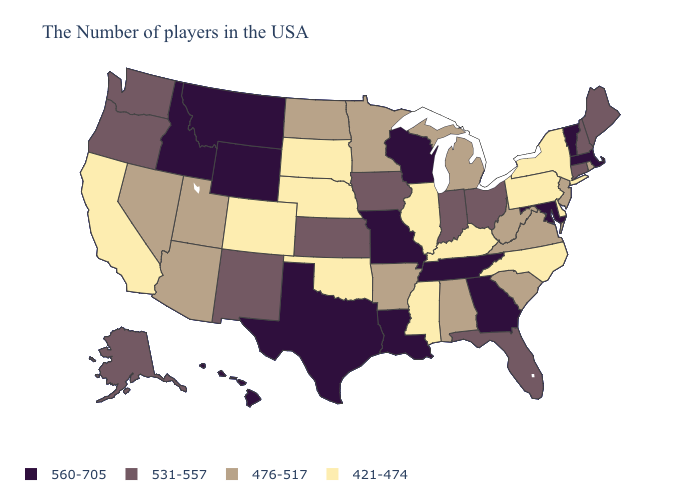Name the states that have a value in the range 476-517?
Write a very short answer. Rhode Island, New Jersey, Virginia, South Carolina, West Virginia, Michigan, Alabama, Arkansas, Minnesota, North Dakota, Utah, Arizona, Nevada. Which states have the lowest value in the Northeast?
Write a very short answer. New York, Pennsylvania. Does Delaware have the same value as Maine?
Write a very short answer. No. Name the states that have a value in the range 560-705?
Write a very short answer. Massachusetts, Vermont, Maryland, Georgia, Tennessee, Wisconsin, Louisiana, Missouri, Texas, Wyoming, Montana, Idaho, Hawaii. Name the states that have a value in the range 476-517?
Be succinct. Rhode Island, New Jersey, Virginia, South Carolina, West Virginia, Michigan, Alabama, Arkansas, Minnesota, North Dakota, Utah, Arizona, Nevada. What is the lowest value in the South?
Keep it brief. 421-474. Among the states that border Mississippi , does Arkansas have the highest value?
Keep it brief. No. Name the states that have a value in the range 560-705?
Be succinct. Massachusetts, Vermont, Maryland, Georgia, Tennessee, Wisconsin, Louisiana, Missouri, Texas, Wyoming, Montana, Idaho, Hawaii. Among the states that border Nebraska , which have the lowest value?
Short answer required. South Dakota, Colorado. How many symbols are there in the legend?
Short answer required. 4. Name the states that have a value in the range 421-474?
Concise answer only. New York, Delaware, Pennsylvania, North Carolina, Kentucky, Illinois, Mississippi, Nebraska, Oklahoma, South Dakota, Colorado, California. What is the lowest value in the USA?
Give a very brief answer. 421-474. Which states have the lowest value in the USA?
Give a very brief answer. New York, Delaware, Pennsylvania, North Carolina, Kentucky, Illinois, Mississippi, Nebraska, Oklahoma, South Dakota, Colorado, California. Which states have the lowest value in the USA?
Short answer required. New York, Delaware, Pennsylvania, North Carolina, Kentucky, Illinois, Mississippi, Nebraska, Oklahoma, South Dakota, Colorado, California. Does the map have missing data?
Answer briefly. No. 